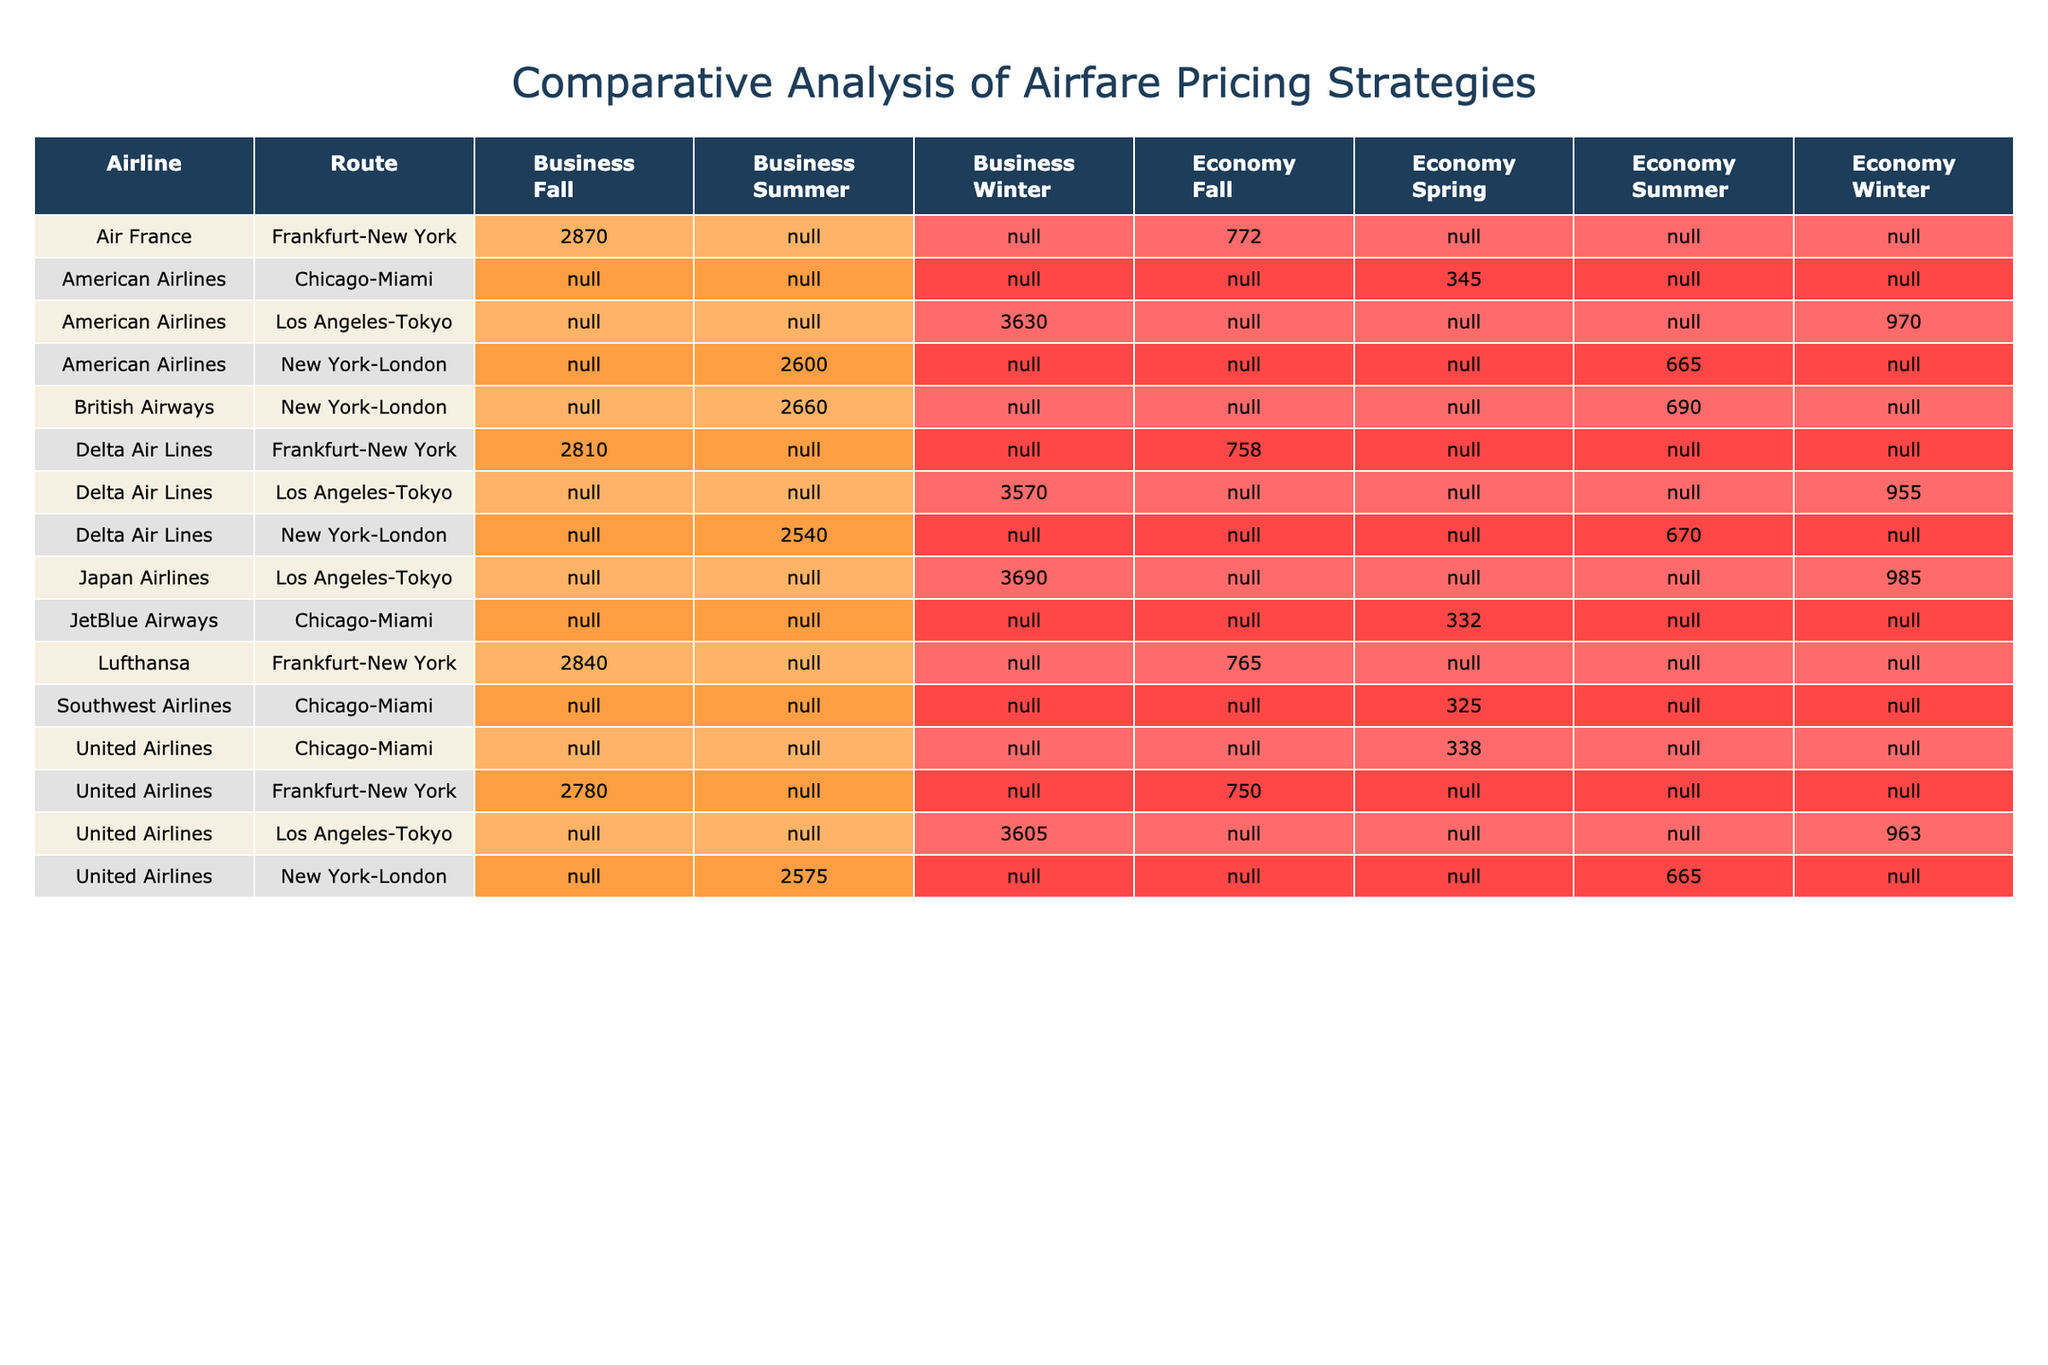What is the total fare for Delta Air Lines on the New York-London route during the summer in Economy class? From the table, look for Delta Air Lines under the New York-London route and identify the Economy class in the summer. The total fare listed is 670.
Answer: 670 Which airline has the highest total fare for Business class on the New York-London route during summer? In the table, check the Business class fares for the New York-London route. The total fares are: American Airlines 2600, Delta Air Lines 2540, United Airlines 2575, and British Airways 2660. British Airways has the highest fare at 2660.
Answer: British Airways What is the average total fare for Economy class across all airlines on the Frankfurt-New York route during the fall? From the Frankfurt-New York route in Economy class, total fares are: Lufthansa 765, United Airlines 750, Delta Air Lines 758, and Air France 772. Adding these gives 765 + 750 + 758 + 772 = 3045. Dividing by 4 gives an average of 3045/4 = 761.25.
Answer: 761.25 Is the total fare for American Airlines in Business class during winter higher than the total fare for Japan Airlines in the same class? Check the Business class fares for winter: American Airlines is 3630 and Japan Airlines is 3690. Since 3630 is less than 3690, the statement is false.
Answer: No Which airline has the second lowest total fare for Economy class on the Chicago-Miami route during spring? On the Chicago-Miami route during spring, the total fares for Economy class are: Southwest Airlines 325, American Airlines 345, United Airlines 338, and JetBlue Airways 332. Arranging them in ascending order shows that JetBlue Airways has the second lowest fare at 332.
Answer: JetBlue Airways What is the difference in total fare between the highest and lowest total fare for Economy class on the Los Angeles-Tokyo route in winter? The total fares for Economy class on the Los Angeles-Tokyo route in winter are: American Airlines 970, Delta Air Lines 955, United Airlines 963, and Japan Airlines 985. The highest fare is Japan Airlines at 985, and the lowest is Delta Air Lines at 955. The difference is 985 - 955 = 30.
Answer: 30 Are the total fares for Business class in fall higher than in summer for any airline? The total fares for Business class are: American Airlines 2600 (summer) vs 2400 (fall), Delta Air Lines 2540 (summer) vs 2375 (fall), United Airlines 2575 (summer) vs 2350 (fall), and British Airways 2660 (summer) vs 2425 (fall). All fall fares are lower than summer fares, making the statement false.
Answer: No What is the total share of market held by American Airlines on the New York-London route for both Economy and Business classes combined? For the New York-London route, American Airlines holds a market share of 0.28 (Economy) + 0.30 (Business) = 0.58.
Answer: 0.58 